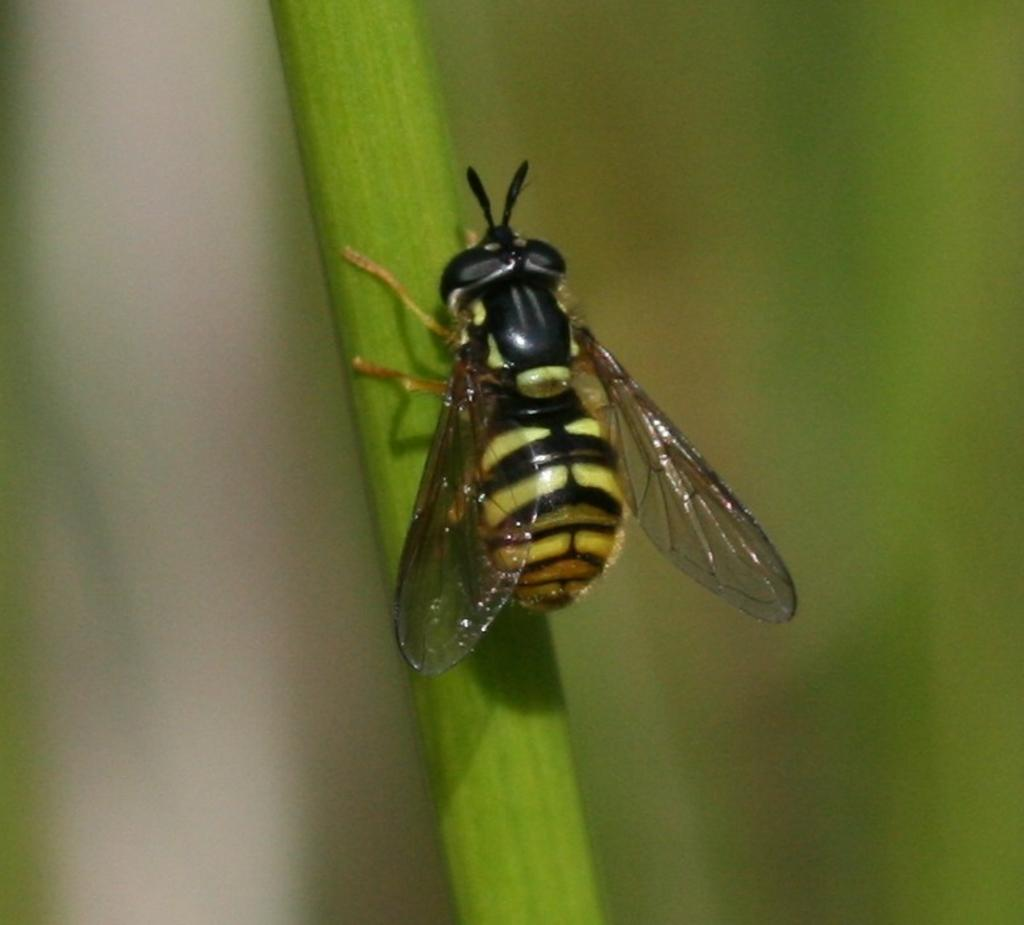What type of creature is in the image? There is an insect in the image. What color is the insect? The insect is black in color. What is the insect sitting on in the image? The insect is on a green color strip. How would you describe the background of the image? The background of the image is green and blurred. How does the insect try to use the glue in the image? There is no glue present in the image, and therefore the insect cannot attempt to use it. 